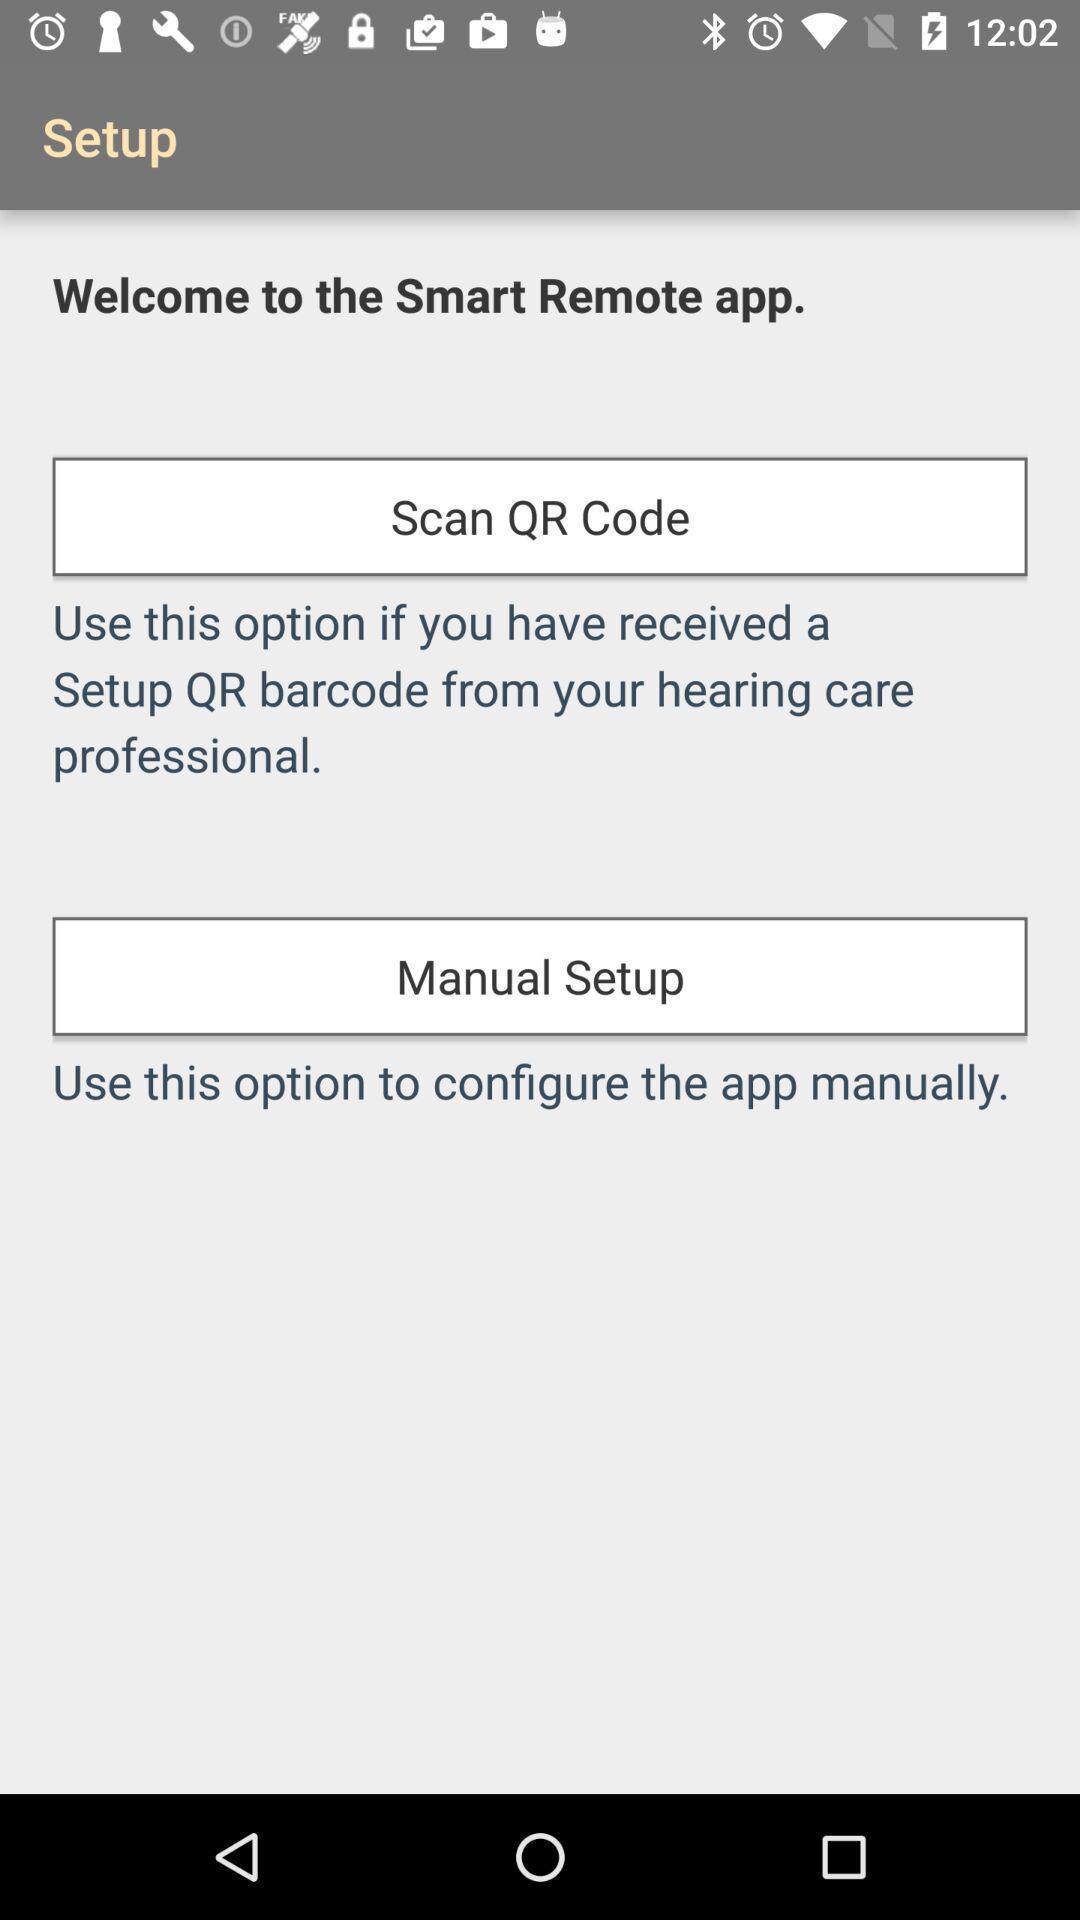Tell me what you see in this picture. Welcome page. 